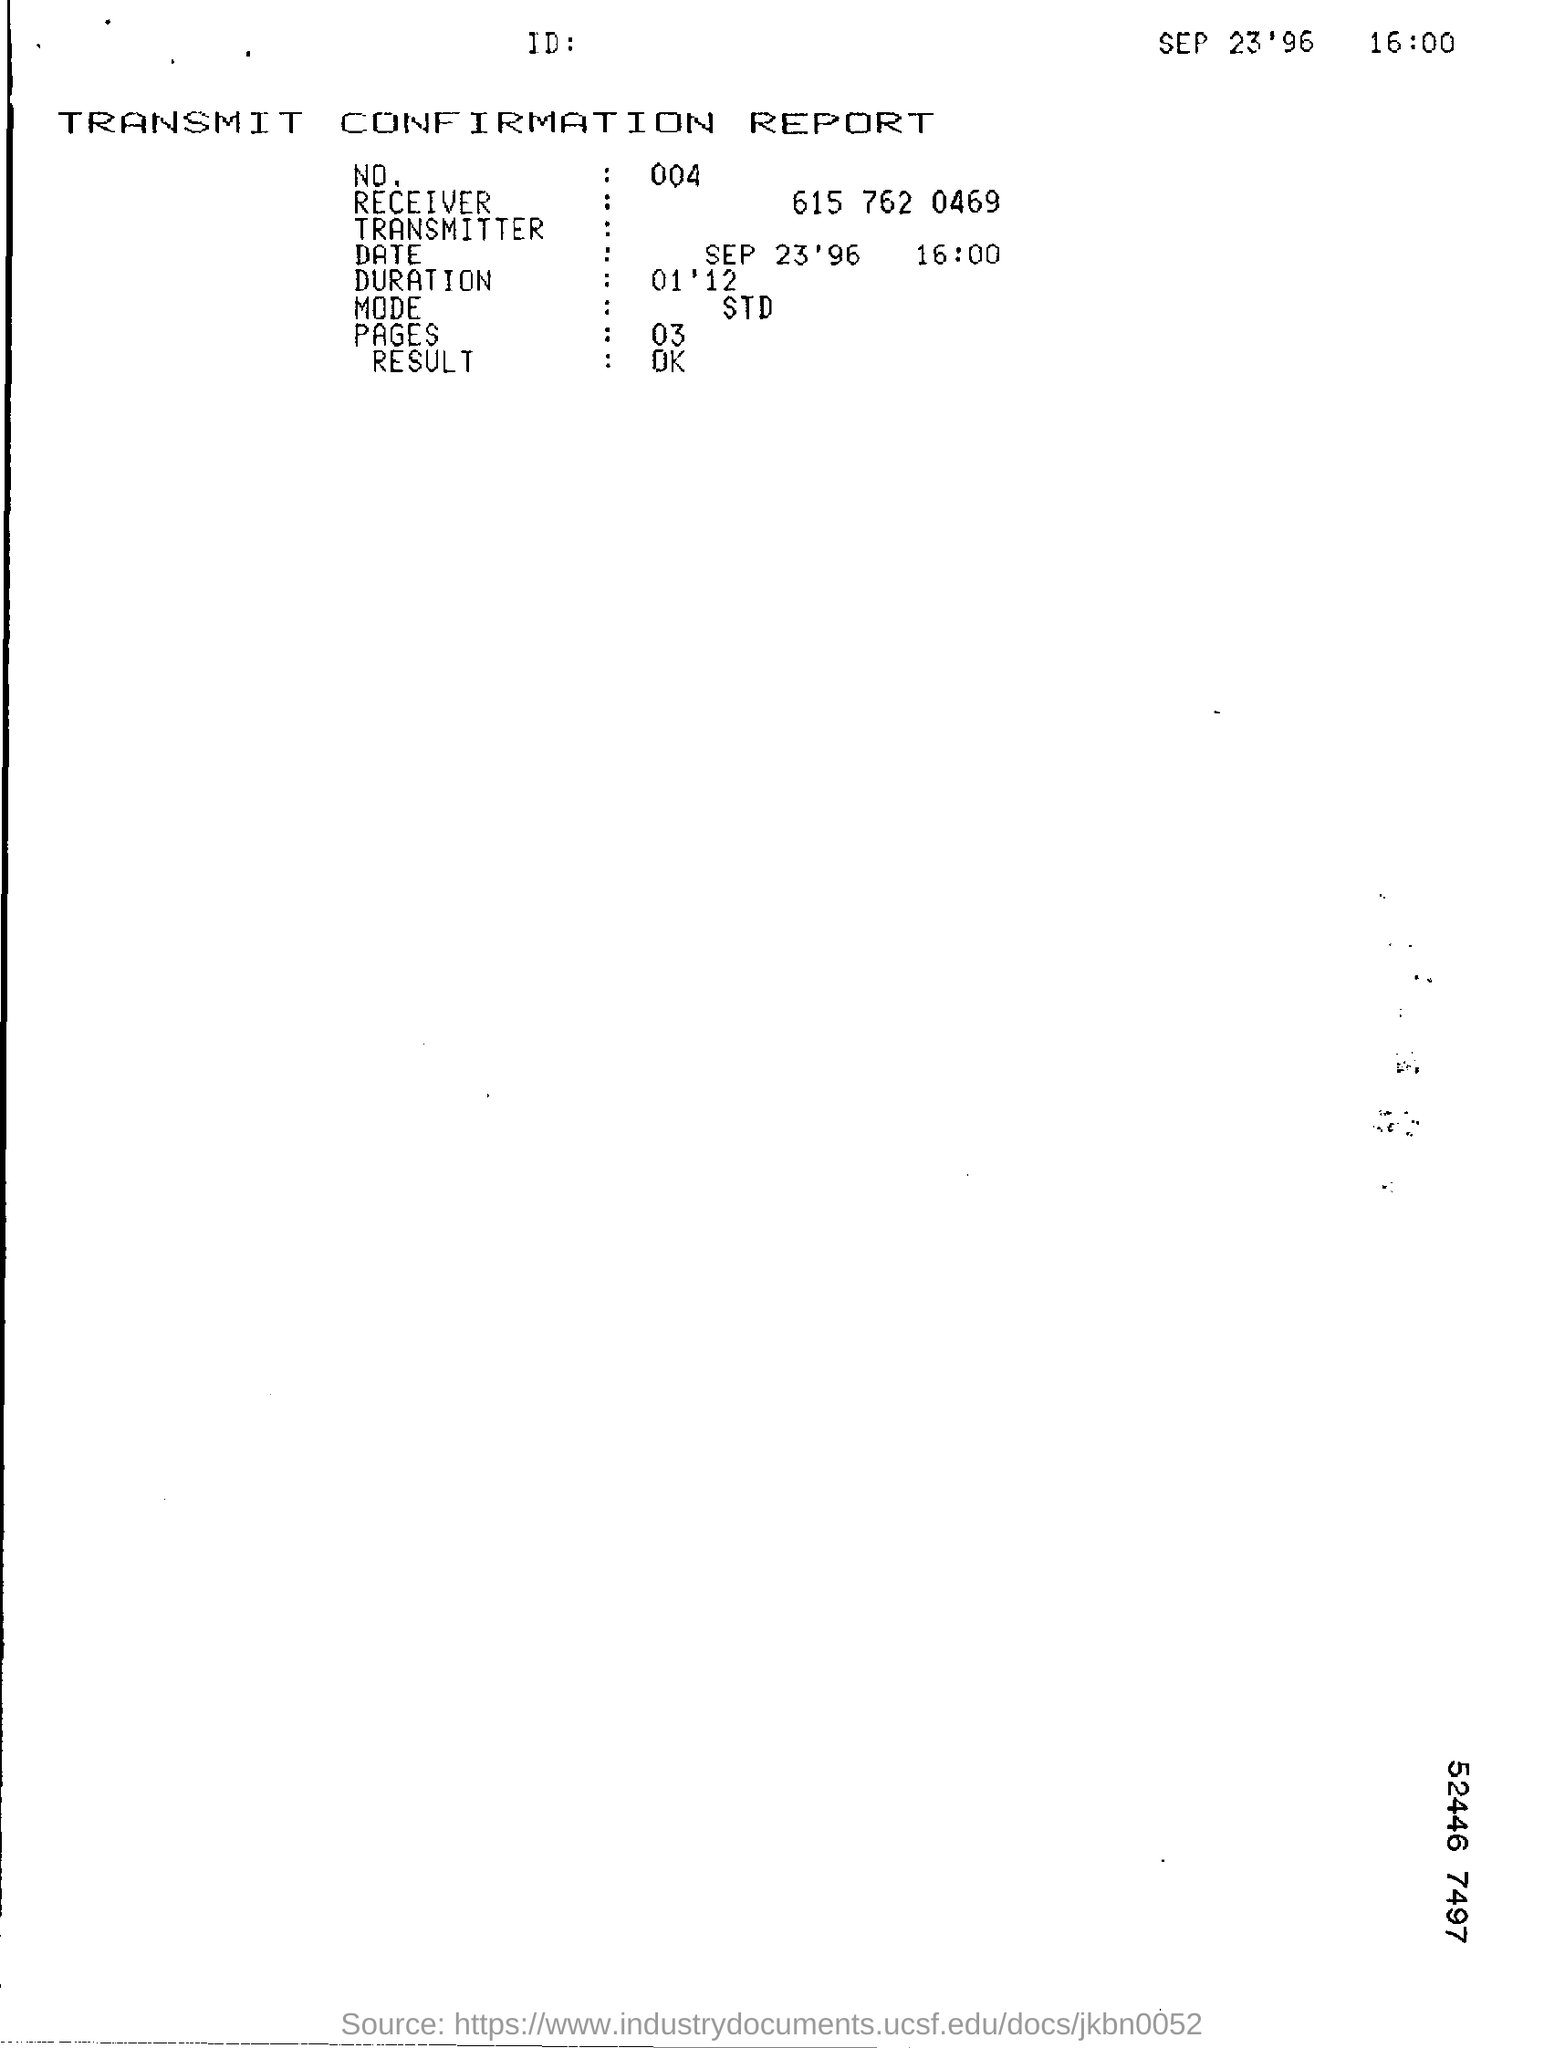What is the result of the TRANSMIT CONFIRMATION REPORT?
Your answer should be compact. OK. 